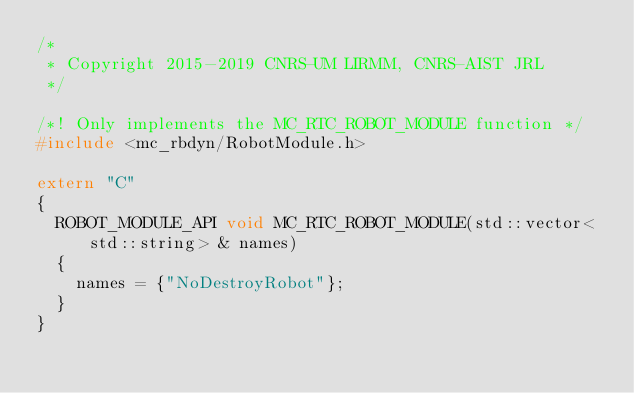Convert code to text. <code><loc_0><loc_0><loc_500><loc_500><_C++_>/*
 * Copyright 2015-2019 CNRS-UM LIRMM, CNRS-AIST JRL
 */

/*! Only implements the MC_RTC_ROBOT_MODULE function */
#include <mc_rbdyn/RobotModule.h>

extern "C"
{
  ROBOT_MODULE_API void MC_RTC_ROBOT_MODULE(std::vector<std::string> & names)
  {
    names = {"NoDestroyRobot"};
  }
}
</code> 